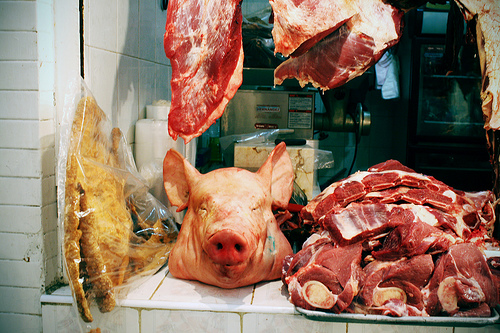<image>
Is the meat slab on the pig head? No. The meat slab is not positioned on the pig head. They may be near each other, but the meat slab is not supported by or resting on top of the pig head. 